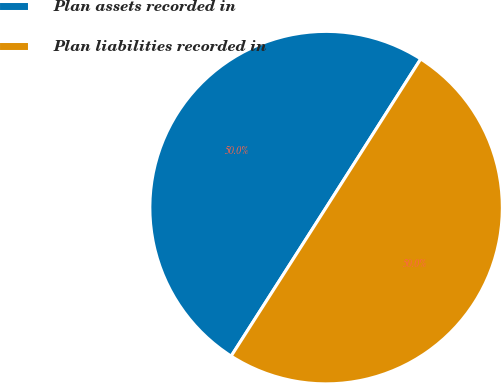Convert chart. <chart><loc_0><loc_0><loc_500><loc_500><pie_chart><fcel>Plan assets recorded in<fcel>Plan liabilities recorded in<nl><fcel>49.97%<fcel>50.03%<nl></chart> 